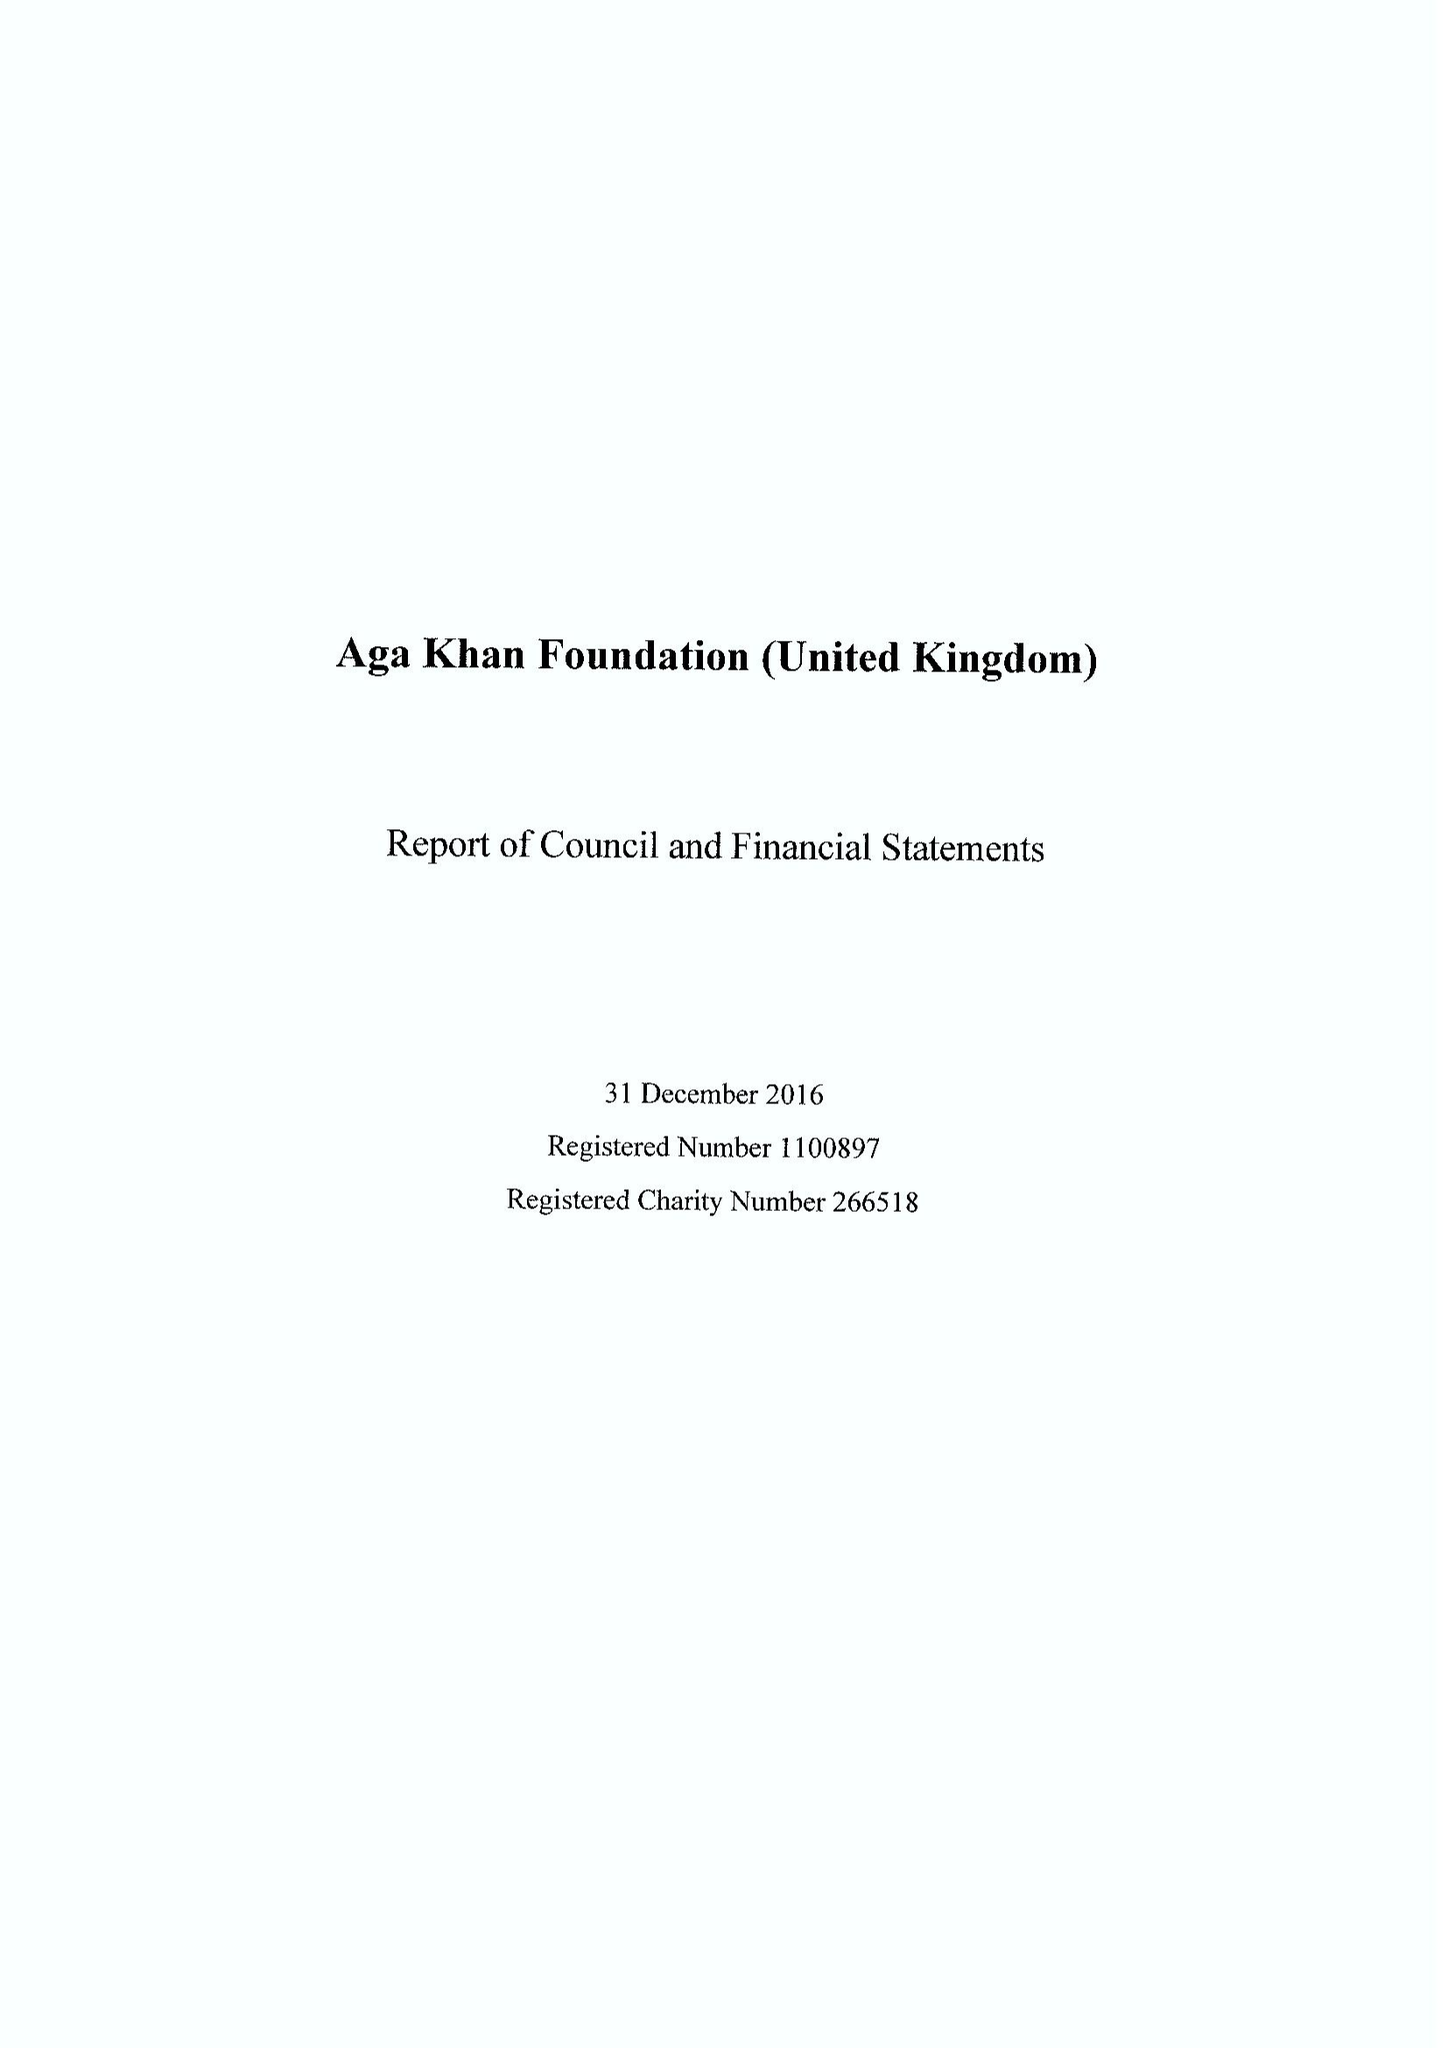What is the value for the address__post_town?
Answer the question using a single word or phrase. LONDON 